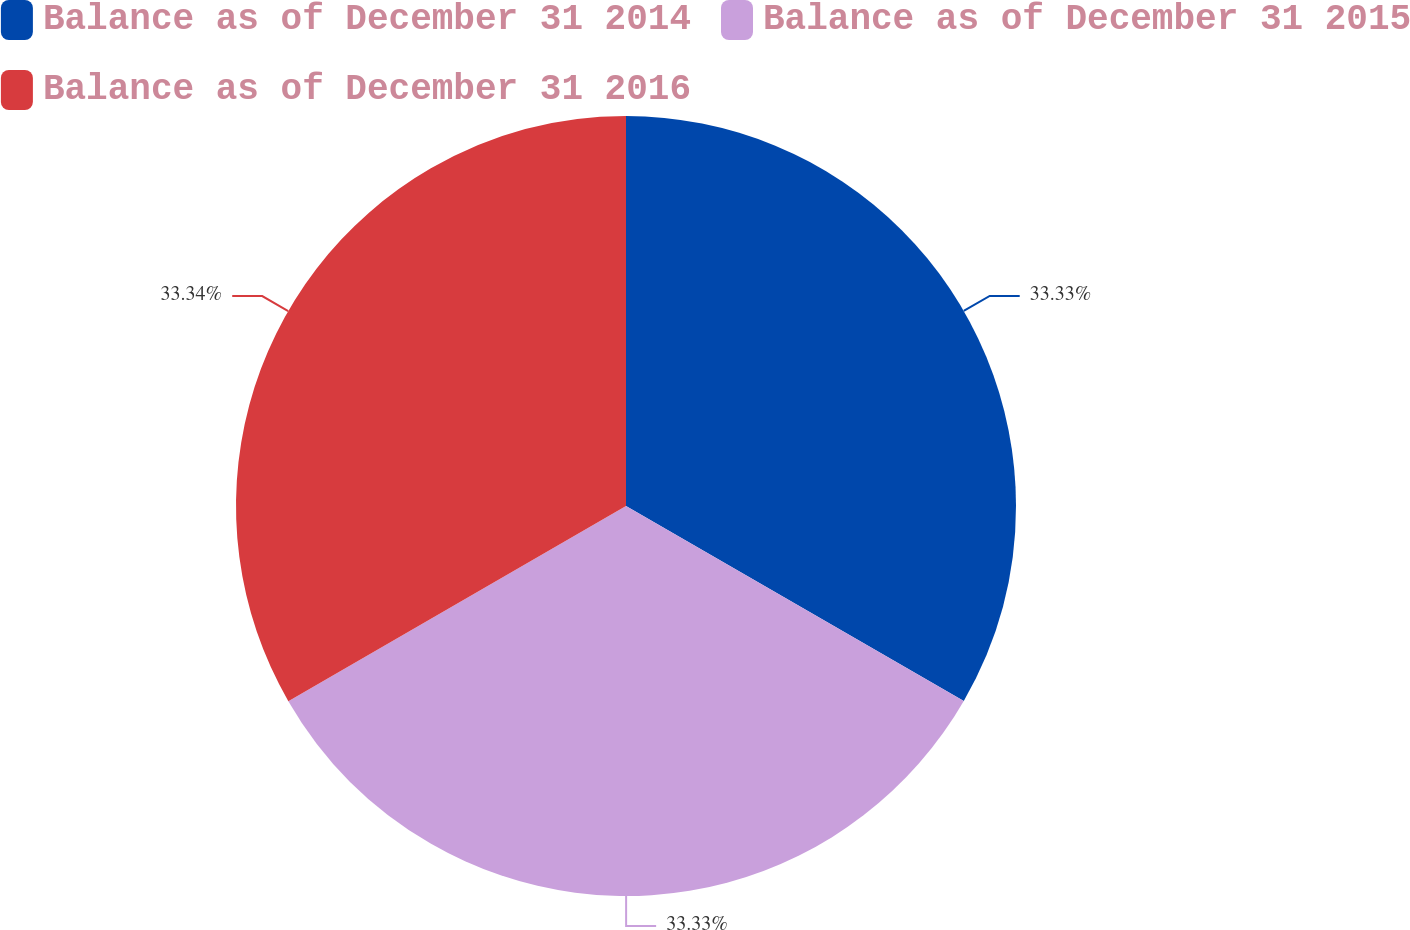Convert chart. <chart><loc_0><loc_0><loc_500><loc_500><pie_chart><fcel>Balance as of December 31 2014<fcel>Balance as of December 31 2015<fcel>Balance as of December 31 2016<nl><fcel>33.33%<fcel>33.33%<fcel>33.34%<nl></chart> 